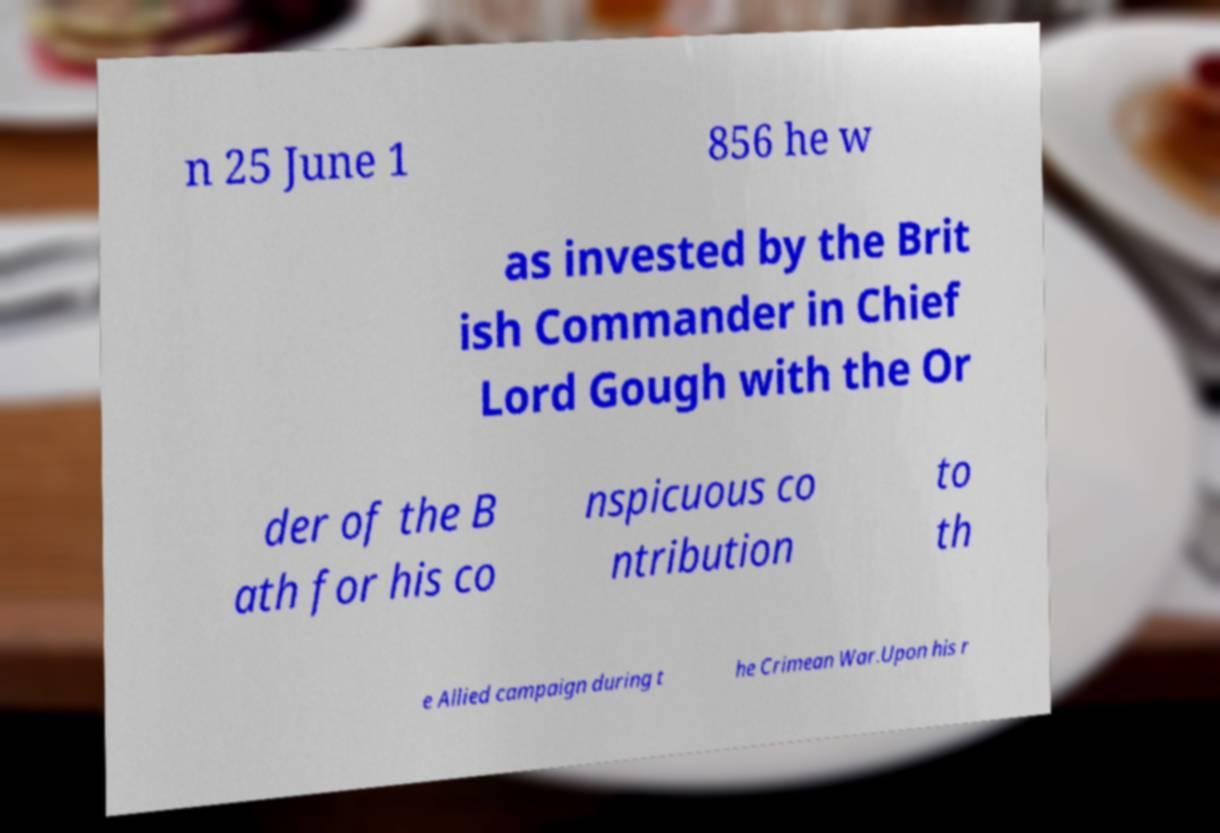I need the written content from this picture converted into text. Can you do that? n 25 June 1 856 he w as invested by the Brit ish Commander in Chief Lord Gough with the Or der of the B ath for his co nspicuous co ntribution to th e Allied campaign during t he Crimean War.Upon his r 